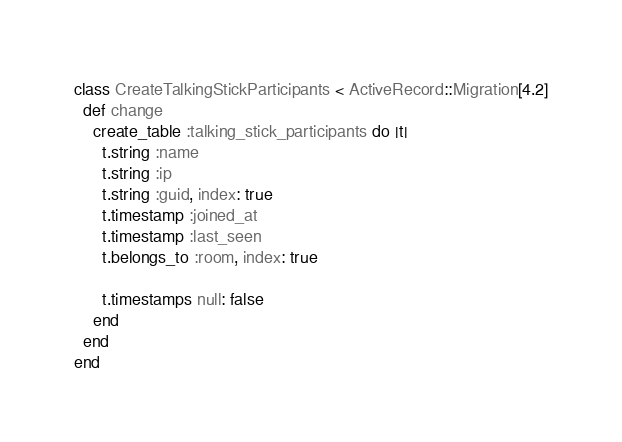<code> <loc_0><loc_0><loc_500><loc_500><_Ruby_>class CreateTalkingStickParticipants < ActiveRecord::Migration[4.2]
  def change
    create_table :talking_stick_participants do |t|
      t.string :name
      t.string :ip
      t.string :guid, index: true
      t.timestamp :joined_at
      t.timestamp :last_seen
      t.belongs_to :room, index: true

      t.timestamps null: false
    end
  end
end
</code> 